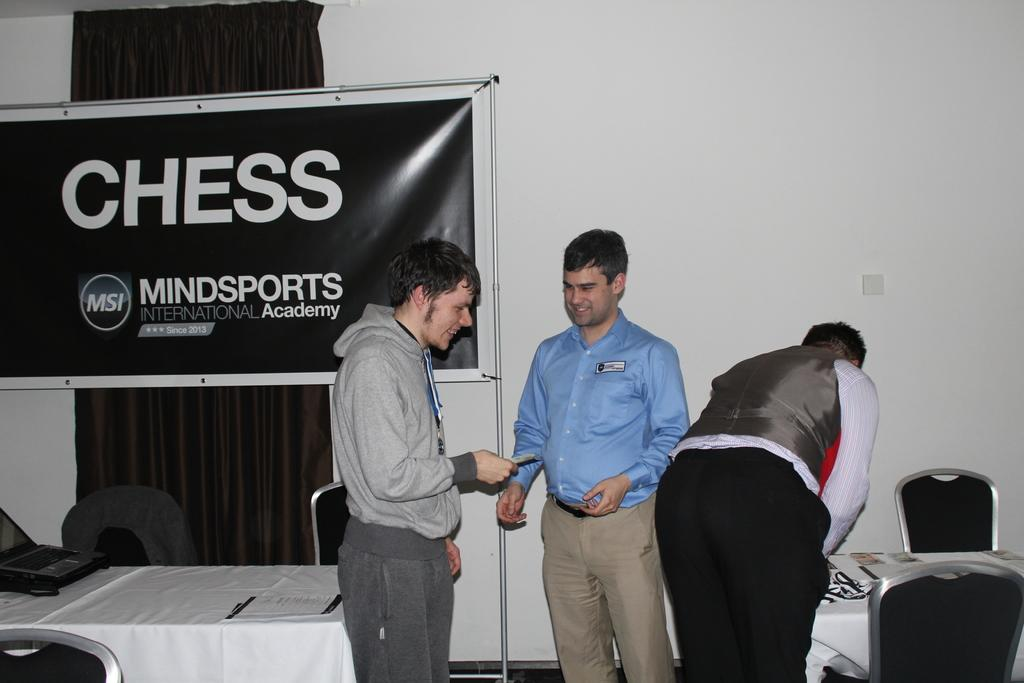How many men are present in the image? There are three men in the image. What is the facial expression of the men? Two of the men are smiling. What type of furniture is visible in the image? There are chairs and tables in the image. What can be seen in the background of the image? There is a banner and a wall in the background of the image. Can you tell me what type of net the men are using in the image? There is no net present in the image. Is the daughter of one of the men visible in the image? There is no mention of a daughter or any other person besides the three men in the image. 